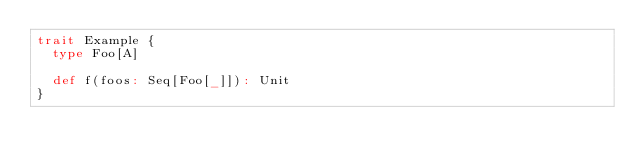Convert code to text. <code><loc_0><loc_0><loc_500><loc_500><_Scala_>trait Example {
  type Foo[A]

  def f(foos: Seq[Foo[_]]): Unit
}
</code> 